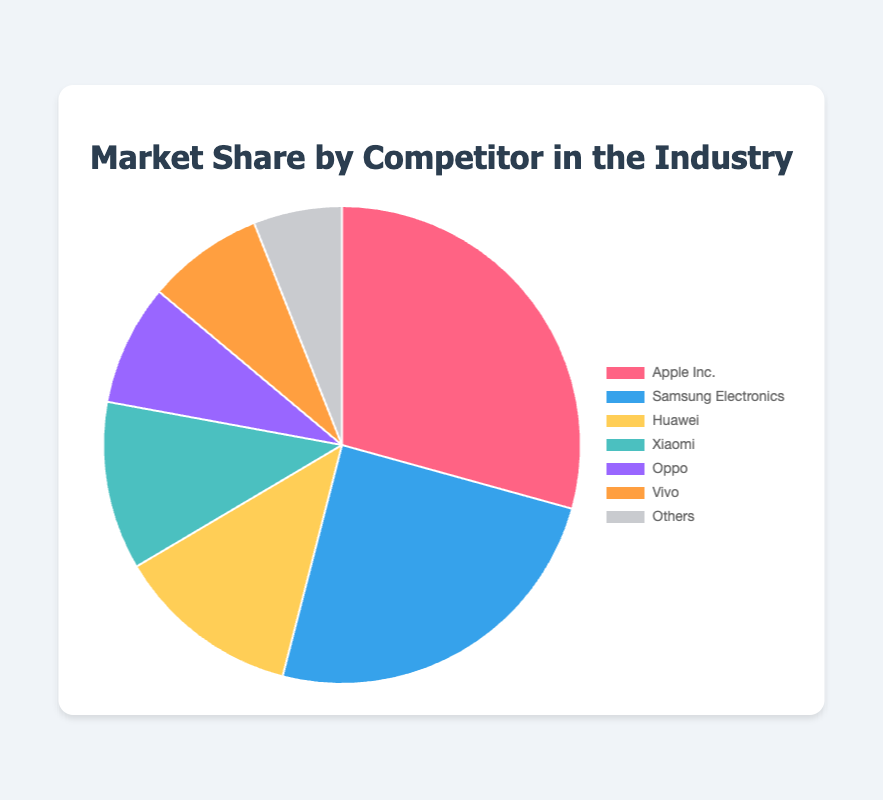What is the market share of the top competitor, Apple Inc.? Apple Inc.'s market share is directly indicated in the chart.
Answer: 29.3% Among the listed competitors, which company has the smallest market share? By looking at the market share percentages, "Others" has the smallest share.
Answer: Others What is the combined market share of Huawei, Xiaomi, and Oppo? Summing the market shares of Huawei (12.5%), Xiaomi (11.4%), and Oppo (8.2%) gives 12.5 + 11.4 + 8.2 = 32.1%.
Answer: 32.1% How much greater is Apple Inc.'s market share compared to Vivo's market share? Subtract Vivo's market share (7.9%) from Apple Inc.'s market share (29.3%) to find the difference: 29.3 - 7.9 = 21.4%.
Answer: 21.4% Which competitors combined have a market share equal to or greater than that of Samsung Electronics? Combining the market shares of Huawei (12.5%) and Xiaomi (11.4%) gives 12.5 + 11.4 = 23.9%, which is less, while adding Oppo (8.2%) reaches 32.1%, more than Samsung's 24.7%.
Answer: Huawei, Xiaomi, Oppo Which color corresponds to Samsung Electronics and its respective market share value? Samsung Electronics is represented in blue on the pie chart, and its market share is 24.7%.
Answer: Blue, 24.7% Comparing Xiaomi and Vivo, which company has a higher market share, and by how much? Subtract Vivo's market share (7.9%) from Xiaomi's market share (11.4%) to find the difference: 11.4 - 7.9 = 3.5%.
Answer: Xiaomi, 3.5% What proportion of the market is held by competitors categorized under "Others"? The market share of "Others" is directly labeled in the chart as 6%.
Answer: 6% Summing the market shares, what is the total share accounted for by all the competitors listed? Adding up all the market shares: 29.3 + 24.7 + 12.5 + 11.4 + 8.2 + 7.9 + 6.0 = 100%.
Answer: 100% If Apple Inc. and Samsung Electronics were to merge, what would their combined market share be? Adding Apple Inc.'s market share (29.3%) to Samsung Electronics' market share (24.7%) gives 29.3 + 24.7 = 54%.
Answer: 54% 